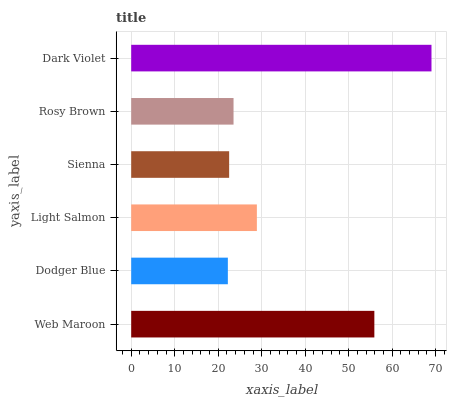Is Dodger Blue the minimum?
Answer yes or no. Yes. Is Dark Violet the maximum?
Answer yes or no. Yes. Is Light Salmon the minimum?
Answer yes or no. No. Is Light Salmon the maximum?
Answer yes or no. No. Is Light Salmon greater than Dodger Blue?
Answer yes or no. Yes. Is Dodger Blue less than Light Salmon?
Answer yes or no. Yes. Is Dodger Blue greater than Light Salmon?
Answer yes or no. No. Is Light Salmon less than Dodger Blue?
Answer yes or no. No. Is Light Salmon the high median?
Answer yes or no. Yes. Is Rosy Brown the low median?
Answer yes or no. Yes. Is Dodger Blue the high median?
Answer yes or no. No. Is Dodger Blue the low median?
Answer yes or no. No. 